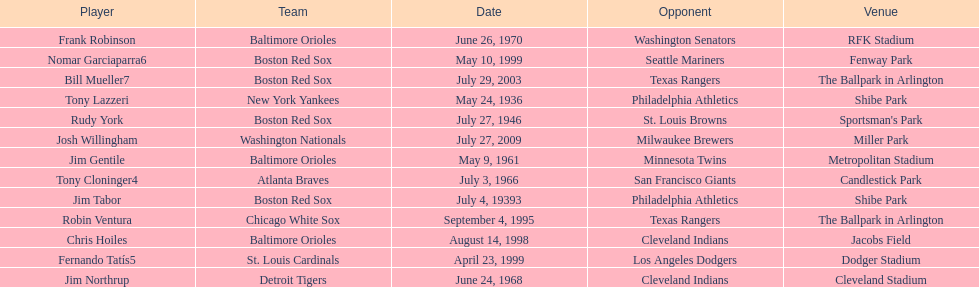Who was the opponent for the boston red sox on july 27, 1946? St. Louis Browns. 